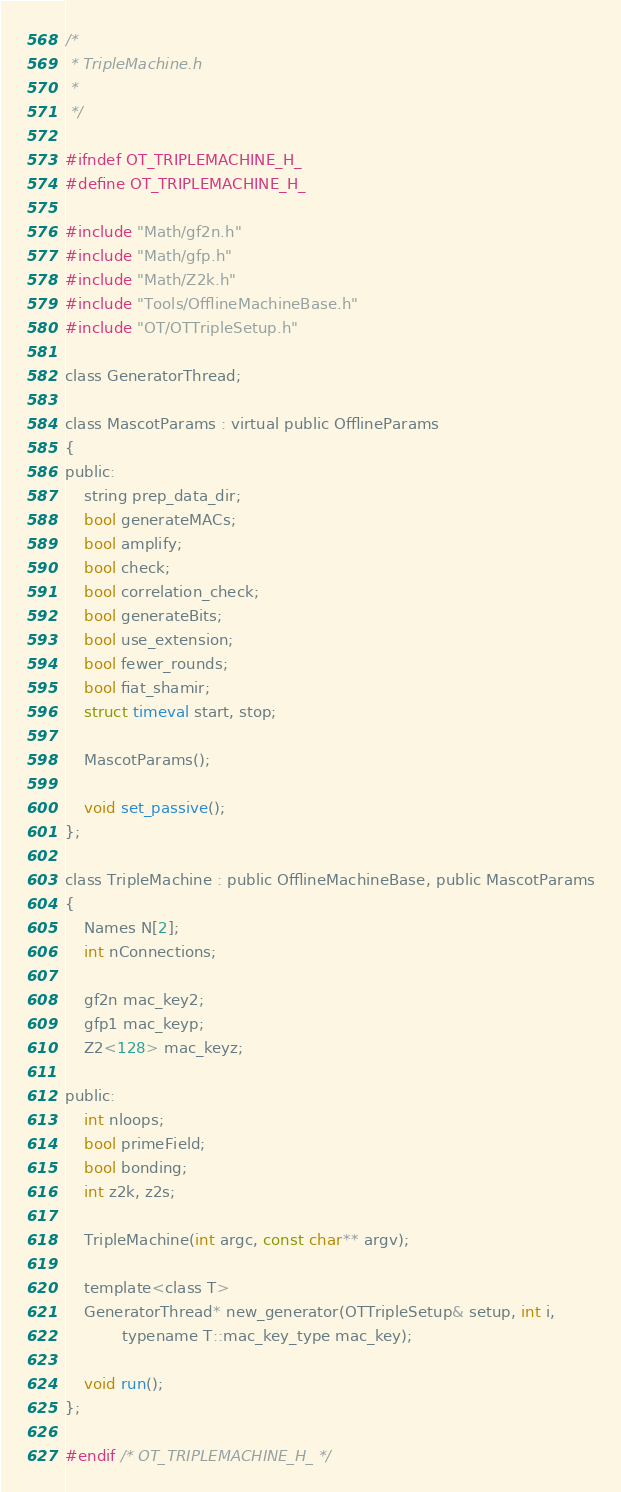Convert code to text. <code><loc_0><loc_0><loc_500><loc_500><_C_>/*
 * TripleMachine.h
 *
 */

#ifndef OT_TRIPLEMACHINE_H_
#define OT_TRIPLEMACHINE_H_

#include "Math/gf2n.h"
#include "Math/gfp.h"
#include "Math/Z2k.h"
#include "Tools/OfflineMachineBase.h"
#include "OT/OTTripleSetup.h"

class GeneratorThread;

class MascotParams : virtual public OfflineParams
{
public:
    string prep_data_dir;
    bool generateMACs;
    bool amplify;
    bool check;
    bool correlation_check;
    bool generateBits;
    bool use_extension;
    bool fewer_rounds;
    bool fiat_shamir;
    struct timeval start, stop;

    MascotParams();

    void set_passive();
};

class TripleMachine : public OfflineMachineBase, public MascotParams
{
    Names N[2];
    int nConnections;

    gf2n mac_key2;
    gfp1 mac_keyp;
    Z2<128> mac_keyz;

public:
    int nloops;
    bool primeField;
    bool bonding;
    int z2k, z2s;

    TripleMachine(int argc, const char** argv);

    template<class T>
    GeneratorThread* new_generator(OTTripleSetup& setup, int i,
            typename T::mac_key_type mac_key);

    void run();
};

#endif /* OT_TRIPLEMACHINE_H_ */
</code> 